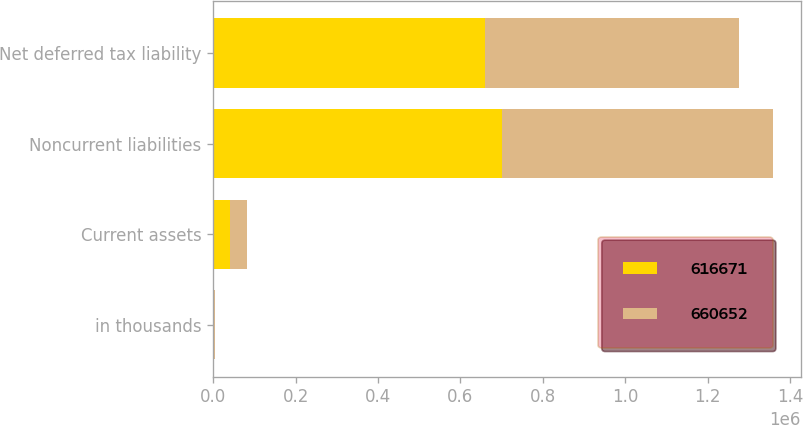Convert chart. <chart><loc_0><loc_0><loc_500><loc_500><stacked_bar_chart><ecel><fcel>in thousands<fcel>Current assets<fcel>Noncurrent liabilities<fcel>Net deferred tax liability<nl><fcel>616671<fcel>2013<fcel>40423<fcel>701075<fcel>660652<nl><fcel>660652<fcel>2012<fcel>40696<fcel>657367<fcel>616671<nl></chart> 